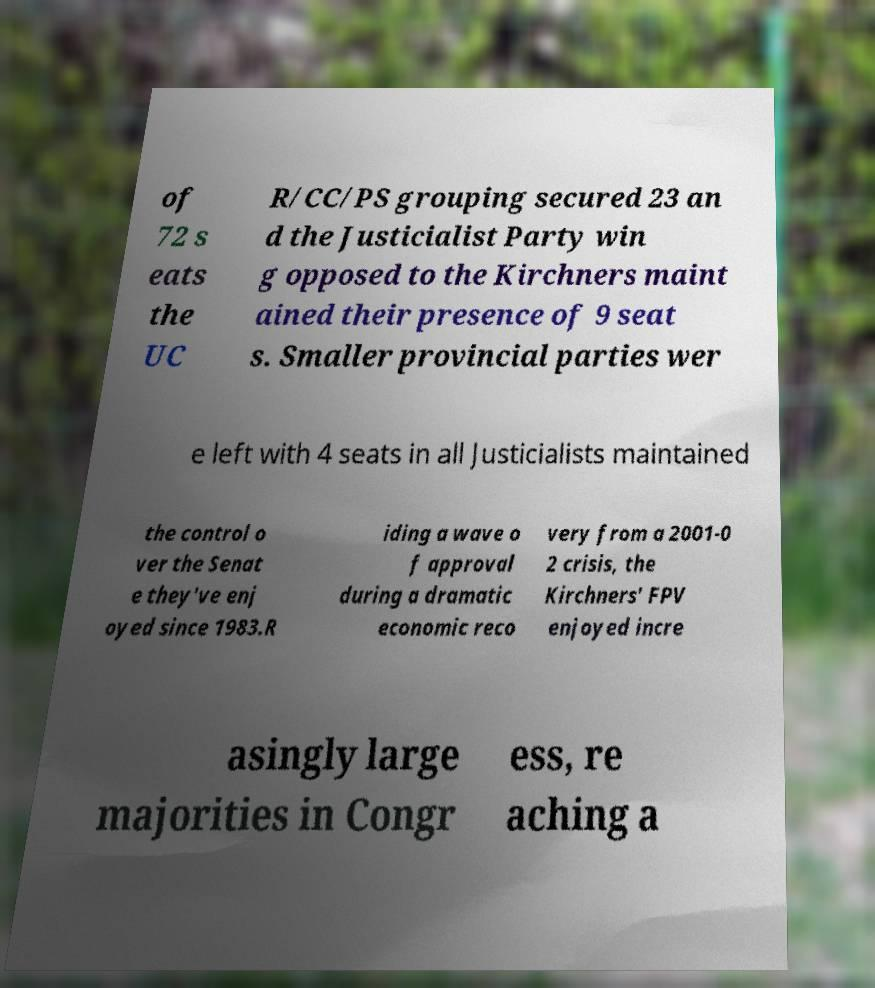I need the written content from this picture converted into text. Can you do that? of 72 s eats the UC R/CC/PS grouping secured 23 an d the Justicialist Party win g opposed to the Kirchners maint ained their presence of 9 seat s. Smaller provincial parties wer e left with 4 seats in all Justicialists maintained the control o ver the Senat e they've enj oyed since 1983.R iding a wave o f approval during a dramatic economic reco very from a 2001-0 2 crisis, the Kirchners' FPV enjoyed incre asingly large majorities in Congr ess, re aching a 